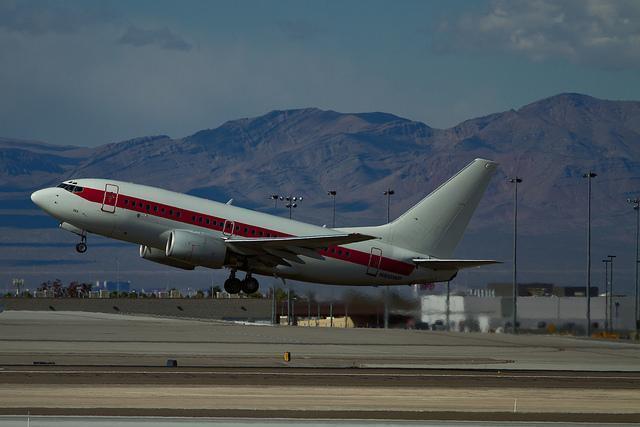How many wheels are on the ground?
Give a very brief answer. 0. How many airplanes are there?
Give a very brief answer. 1. How many of the three people in front are wearing helmets?
Give a very brief answer. 0. 